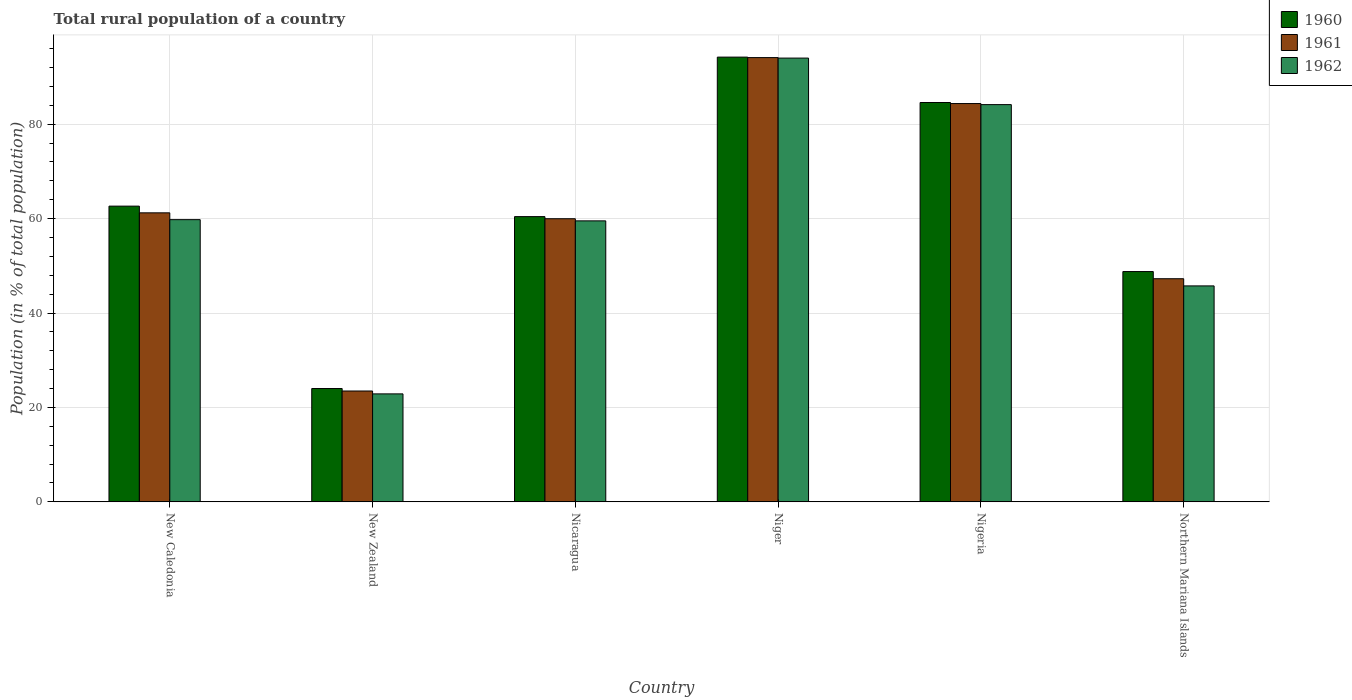How many different coloured bars are there?
Your response must be concise. 3. How many groups of bars are there?
Offer a terse response. 6. Are the number of bars on each tick of the X-axis equal?
Your answer should be compact. Yes. What is the label of the 1st group of bars from the left?
Keep it short and to the point. New Caledonia. In how many cases, is the number of bars for a given country not equal to the number of legend labels?
Provide a succinct answer. 0. What is the rural population in 1962 in New Caledonia?
Your answer should be compact. 59.78. Across all countries, what is the maximum rural population in 1961?
Your response must be concise. 94.1. Across all countries, what is the minimum rural population in 1962?
Your answer should be compact. 22.87. In which country was the rural population in 1961 maximum?
Offer a terse response. Niger. In which country was the rural population in 1960 minimum?
Keep it short and to the point. New Zealand. What is the total rural population in 1961 in the graph?
Your response must be concise. 370.39. What is the difference between the rural population in 1961 in New Zealand and that in Niger?
Give a very brief answer. -70.63. What is the difference between the rural population in 1962 in Niger and the rural population in 1960 in Nicaragua?
Offer a very short reply. 33.58. What is the average rural population in 1960 per country?
Provide a short and direct response. 62.44. What is the difference between the rural population of/in 1961 and rural population of/in 1960 in Nicaragua?
Your answer should be very brief. -0.45. In how many countries, is the rural population in 1960 greater than 28 %?
Offer a very short reply. 5. What is the ratio of the rural population in 1960 in New Caledonia to that in Niger?
Keep it short and to the point. 0.66. Is the rural population in 1962 in Niger less than that in Nigeria?
Give a very brief answer. No. What is the difference between the highest and the second highest rural population in 1960?
Offer a terse response. -21.95. What is the difference between the highest and the lowest rural population in 1962?
Give a very brief answer. 71.13. In how many countries, is the rural population in 1960 greater than the average rural population in 1960 taken over all countries?
Ensure brevity in your answer.  3. What does the 1st bar from the right in Nicaragua represents?
Give a very brief answer. 1962. Are all the bars in the graph horizontal?
Offer a terse response. No. What is the difference between two consecutive major ticks on the Y-axis?
Keep it short and to the point. 20. Where does the legend appear in the graph?
Provide a succinct answer. Top right. How many legend labels are there?
Offer a very short reply. 3. How are the legend labels stacked?
Keep it short and to the point. Vertical. What is the title of the graph?
Keep it short and to the point. Total rural population of a country. Does "1972" appear as one of the legend labels in the graph?
Give a very brief answer. No. What is the label or title of the X-axis?
Your answer should be very brief. Country. What is the label or title of the Y-axis?
Make the answer very short. Population (in % of total population). What is the Population (in % of total population) of 1960 in New Caledonia?
Keep it short and to the point. 62.64. What is the Population (in % of total population) in 1961 in New Caledonia?
Keep it short and to the point. 61.22. What is the Population (in % of total population) of 1962 in New Caledonia?
Your response must be concise. 59.78. What is the Population (in % of total population) in 1960 in New Zealand?
Keep it short and to the point. 24. What is the Population (in % of total population) of 1961 in New Zealand?
Provide a short and direct response. 23.48. What is the Population (in % of total population) in 1962 in New Zealand?
Keep it short and to the point. 22.87. What is the Population (in % of total population) in 1960 in Nicaragua?
Your answer should be very brief. 60.42. What is the Population (in % of total population) in 1961 in Nicaragua?
Your response must be concise. 59.97. What is the Population (in % of total population) in 1962 in Nicaragua?
Keep it short and to the point. 59.52. What is the Population (in % of total population) of 1960 in Niger?
Give a very brief answer. 94.21. What is the Population (in % of total population) in 1961 in Niger?
Provide a short and direct response. 94.1. What is the Population (in % of total population) of 1962 in Niger?
Make the answer very short. 94. What is the Population (in % of total population) of 1960 in Nigeria?
Give a very brief answer. 84.59. What is the Population (in % of total population) in 1961 in Nigeria?
Offer a very short reply. 84.37. What is the Population (in % of total population) in 1962 in Nigeria?
Keep it short and to the point. 84.14. What is the Population (in % of total population) in 1960 in Northern Mariana Islands?
Offer a very short reply. 48.78. What is the Population (in % of total population) in 1961 in Northern Mariana Islands?
Keep it short and to the point. 47.26. What is the Population (in % of total population) of 1962 in Northern Mariana Islands?
Provide a short and direct response. 45.74. Across all countries, what is the maximum Population (in % of total population) of 1960?
Your answer should be very brief. 94.21. Across all countries, what is the maximum Population (in % of total population) in 1961?
Your answer should be compact. 94.1. Across all countries, what is the maximum Population (in % of total population) of 1962?
Give a very brief answer. 94. Across all countries, what is the minimum Population (in % of total population) of 1960?
Provide a succinct answer. 24. Across all countries, what is the minimum Population (in % of total population) in 1961?
Give a very brief answer. 23.48. Across all countries, what is the minimum Population (in % of total population) of 1962?
Offer a very short reply. 22.87. What is the total Population (in % of total population) in 1960 in the graph?
Ensure brevity in your answer.  374.64. What is the total Population (in % of total population) of 1961 in the graph?
Ensure brevity in your answer.  370.39. What is the total Population (in % of total population) in 1962 in the graph?
Ensure brevity in your answer.  366.04. What is the difference between the Population (in % of total population) in 1960 in New Caledonia and that in New Zealand?
Your answer should be compact. 38.64. What is the difference between the Population (in % of total population) of 1961 in New Caledonia and that in New Zealand?
Offer a terse response. 37.74. What is the difference between the Population (in % of total population) of 1962 in New Caledonia and that in New Zealand?
Your response must be concise. 36.91. What is the difference between the Population (in % of total population) of 1960 in New Caledonia and that in Nicaragua?
Offer a terse response. 2.22. What is the difference between the Population (in % of total population) of 1961 in New Caledonia and that in Nicaragua?
Keep it short and to the point. 1.25. What is the difference between the Population (in % of total population) in 1962 in New Caledonia and that in Nicaragua?
Provide a succinct answer. 0.26. What is the difference between the Population (in % of total population) of 1960 in New Caledonia and that in Niger?
Keep it short and to the point. -31.57. What is the difference between the Population (in % of total population) in 1961 in New Caledonia and that in Niger?
Give a very brief answer. -32.88. What is the difference between the Population (in % of total population) of 1962 in New Caledonia and that in Niger?
Ensure brevity in your answer.  -34.22. What is the difference between the Population (in % of total population) in 1960 in New Caledonia and that in Nigeria?
Offer a very short reply. -21.95. What is the difference between the Population (in % of total population) of 1961 in New Caledonia and that in Nigeria?
Your answer should be compact. -23.15. What is the difference between the Population (in % of total population) of 1962 in New Caledonia and that in Nigeria?
Keep it short and to the point. -24.37. What is the difference between the Population (in % of total population) of 1960 in New Caledonia and that in Northern Mariana Islands?
Provide a succinct answer. 13.86. What is the difference between the Population (in % of total population) in 1961 in New Caledonia and that in Northern Mariana Islands?
Provide a short and direct response. 13.96. What is the difference between the Population (in % of total population) of 1962 in New Caledonia and that in Northern Mariana Islands?
Your response must be concise. 14.04. What is the difference between the Population (in % of total population) of 1960 in New Zealand and that in Nicaragua?
Your answer should be compact. -36.42. What is the difference between the Population (in % of total population) of 1961 in New Zealand and that in Nicaragua?
Make the answer very short. -36.49. What is the difference between the Population (in % of total population) of 1962 in New Zealand and that in Nicaragua?
Give a very brief answer. -36.65. What is the difference between the Population (in % of total population) in 1960 in New Zealand and that in Niger?
Your answer should be compact. -70.2. What is the difference between the Population (in % of total population) in 1961 in New Zealand and that in Niger?
Your response must be concise. -70.63. What is the difference between the Population (in % of total population) of 1962 in New Zealand and that in Niger?
Your response must be concise. -71.13. What is the difference between the Population (in % of total population) in 1960 in New Zealand and that in Nigeria?
Provide a succinct answer. -60.59. What is the difference between the Population (in % of total population) in 1961 in New Zealand and that in Nigeria?
Give a very brief answer. -60.89. What is the difference between the Population (in % of total population) in 1962 in New Zealand and that in Nigeria?
Keep it short and to the point. -61.27. What is the difference between the Population (in % of total population) of 1960 in New Zealand and that in Northern Mariana Islands?
Provide a short and direct response. -24.78. What is the difference between the Population (in % of total population) in 1961 in New Zealand and that in Northern Mariana Islands?
Keep it short and to the point. -23.78. What is the difference between the Population (in % of total population) of 1962 in New Zealand and that in Northern Mariana Islands?
Your answer should be compact. -22.87. What is the difference between the Population (in % of total population) of 1960 in Nicaragua and that in Niger?
Provide a short and direct response. -33.79. What is the difference between the Population (in % of total population) of 1961 in Nicaragua and that in Niger?
Give a very brief answer. -34.13. What is the difference between the Population (in % of total population) in 1962 in Nicaragua and that in Niger?
Provide a short and direct response. -34.48. What is the difference between the Population (in % of total population) in 1960 in Nicaragua and that in Nigeria?
Ensure brevity in your answer.  -24.17. What is the difference between the Population (in % of total population) of 1961 in Nicaragua and that in Nigeria?
Your response must be concise. -24.4. What is the difference between the Population (in % of total population) of 1962 in Nicaragua and that in Nigeria?
Keep it short and to the point. -24.62. What is the difference between the Population (in % of total population) of 1960 in Nicaragua and that in Northern Mariana Islands?
Give a very brief answer. 11.64. What is the difference between the Population (in % of total population) of 1961 in Nicaragua and that in Northern Mariana Islands?
Ensure brevity in your answer.  12.71. What is the difference between the Population (in % of total population) in 1962 in Nicaragua and that in Northern Mariana Islands?
Give a very brief answer. 13.78. What is the difference between the Population (in % of total population) of 1960 in Niger and that in Nigeria?
Keep it short and to the point. 9.62. What is the difference between the Population (in % of total population) in 1961 in Niger and that in Nigeria?
Provide a short and direct response. 9.74. What is the difference between the Population (in % of total population) of 1962 in Niger and that in Nigeria?
Your answer should be very brief. 9.86. What is the difference between the Population (in % of total population) in 1960 in Niger and that in Northern Mariana Islands?
Offer a very short reply. 45.43. What is the difference between the Population (in % of total population) of 1961 in Niger and that in Northern Mariana Islands?
Keep it short and to the point. 46.84. What is the difference between the Population (in % of total population) in 1962 in Niger and that in Northern Mariana Islands?
Your response must be concise. 48.26. What is the difference between the Population (in % of total population) in 1960 in Nigeria and that in Northern Mariana Islands?
Ensure brevity in your answer.  35.81. What is the difference between the Population (in % of total population) in 1961 in Nigeria and that in Northern Mariana Islands?
Offer a terse response. 37.11. What is the difference between the Population (in % of total population) in 1962 in Nigeria and that in Northern Mariana Islands?
Offer a terse response. 38.4. What is the difference between the Population (in % of total population) of 1960 in New Caledonia and the Population (in % of total population) of 1961 in New Zealand?
Offer a terse response. 39.16. What is the difference between the Population (in % of total population) in 1960 in New Caledonia and the Population (in % of total population) in 1962 in New Zealand?
Your response must be concise. 39.77. What is the difference between the Population (in % of total population) of 1961 in New Caledonia and the Population (in % of total population) of 1962 in New Zealand?
Give a very brief answer. 38.35. What is the difference between the Population (in % of total population) in 1960 in New Caledonia and the Population (in % of total population) in 1961 in Nicaragua?
Make the answer very short. 2.67. What is the difference between the Population (in % of total population) in 1960 in New Caledonia and the Population (in % of total population) in 1962 in Nicaragua?
Ensure brevity in your answer.  3.12. What is the difference between the Population (in % of total population) in 1961 in New Caledonia and the Population (in % of total population) in 1962 in Nicaragua?
Offer a very short reply. 1.7. What is the difference between the Population (in % of total population) in 1960 in New Caledonia and the Population (in % of total population) in 1961 in Niger?
Your answer should be very brief. -31.46. What is the difference between the Population (in % of total population) in 1960 in New Caledonia and the Population (in % of total population) in 1962 in Niger?
Your answer should be compact. -31.36. What is the difference between the Population (in % of total population) of 1961 in New Caledonia and the Population (in % of total population) of 1962 in Niger?
Ensure brevity in your answer.  -32.78. What is the difference between the Population (in % of total population) in 1960 in New Caledonia and the Population (in % of total population) in 1961 in Nigeria?
Provide a short and direct response. -21.73. What is the difference between the Population (in % of total population) in 1960 in New Caledonia and the Population (in % of total population) in 1962 in Nigeria?
Make the answer very short. -21.5. What is the difference between the Population (in % of total population) of 1961 in New Caledonia and the Population (in % of total population) of 1962 in Nigeria?
Give a very brief answer. -22.92. What is the difference between the Population (in % of total population) of 1960 in New Caledonia and the Population (in % of total population) of 1961 in Northern Mariana Islands?
Your answer should be very brief. 15.38. What is the difference between the Population (in % of total population) in 1960 in New Caledonia and the Population (in % of total population) in 1962 in Northern Mariana Islands?
Offer a very short reply. 16.9. What is the difference between the Population (in % of total population) of 1961 in New Caledonia and the Population (in % of total population) of 1962 in Northern Mariana Islands?
Keep it short and to the point. 15.48. What is the difference between the Population (in % of total population) in 1960 in New Zealand and the Population (in % of total population) in 1961 in Nicaragua?
Make the answer very short. -35.97. What is the difference between the Population (in % of total population) in 1960 in New Zealand and the Population (in % of total population) in 1962 in Nicaragua?
Your answer should be compact. -35.52. What is the difference between the Population (in % of total population) of 1961 in New Zealand and the Population (in % of total population) of 1962 in Nicaragua?
Your answer should be compact. -36.04. What is the difference between the Population (in % of total population) of 1960 in New Zealand and the Population (in % of total population) of 1961 in Niger?
Provide a succinct answer. -70.1. What is the difference between the Population (in % of total population) of 1960 in New Zealand and the Population (in % of total population) of 1962 in Niger?
Your response must be concise. -70. What is the difference between the Population (in % of total population) in 1961 in New Zealand and the Population (in % of total population) in 1962 in Niger?
Keep it short and to the point. -70.53. What is the difference between the Population (in % of total population) of 1960 in New Zealand and the Population (in % of total population) of 1961 in Nigeria?
Your response must be concise. -60.37. What is the difference between the Population (in % of total population) in 1960 in New Zealand and the Population (in % of total population) in 1962 in Nigeria?
Make the answer very short. -60.14. What is the difference between the Population (in % of total population) of 1961 in New Zealand and the Population (in % of total population) of 1962 in Nigeria?
Your answer should be compact. -60.67. What is the difference between the Population (in % of total population) of 1960 in New Zealand and the Population (in % of total population) of 1961 in Northern Mariana Islands?
Offer a very short reply. -23.26. What is the difference between the Population (in % of total population) in 1960 in New Zealand and the Population (in % of total population) in 1962 in Northern Mariana Islands?
Your answer should be very brief. -21.74. What is the difference between the Population (in % of total population) in 1961 in New Zealand and the Population (in % of total population) in 1962 in Northern Mariana Islands?
Give a very brief answer. -22.27. What is the difference between the Population (in % of total population) in 1960 in Nicaragua and the Population (in % of total population) in 1961 in Niger?
Ensure brevity in your answer.  -33.69. What is the difference between the Population (in % of total population) of 1960 in Nicaragua and the Population (in % of total population) of 1962 in Niger?
Offer a very short reply. -33.58. What is the difference between the Population (in % of total population) in 1961 in Nicaragua and the Population (in % of total population) in 1962 in Niger?
Ensure brevity in your answer.  -34.03. What is the difference between the Population (in % of total population) of 1960 in Nicaragua and the Population (in % of total population) of 1961 in Nigeria?
Your response must be concise. -23.95. What is the difference between the Population (in % of total population) of 1960 in Nicaragua and the Population (in % of total population) of 1962 in Nigeria?
Your answer should be compact. -23.72. What is the difference between the Population (in % of total population) of 1961 in Nicaragua and the Population (in % of total population) of 1962 in Nigeria?
Give a very brief answer. -24.17. What is the difference between the Population (in % of total population) in 1960 in Nicaragua and the Population (in % of total population) in 1961 in Northern Mariana Islands?
Provide a short and direct response. 13.16. What is the difference between the Population (in % of total population) of 1960 in Nicaragua and the Population (in % of total population) of 1962 in Northern Mariana Islands?
Your answer should be very brief. 14.68. What is the difference between the Population (in % of total population) of 1961 in Nicaragua and the Population (in % of total population) of 1962 in Northern Mariana Islands?
Provide a succinct answer. 14.23. What is the difference between the Population (in % of total population) in 1960 in Niger and the Population (in % of total population) in 1961 in Nigeria?
Your answer should be very brief. 9.84. What is the difference between the Population (in % of total population) in 1960 in Niger and the Population (in % of total population) in 1962 in Nigeria?
Give a very brief answer. 10.06. What is the difference between the Population (in % of total population) of 1961 in Niger and the Population (in % of total population) of 1962 in Nigeria?
Your answer should be very brief. 9.96. What is the difference between the Population (in % of total population) of 1960 in Niger and the Population (in % of total population) of 1961 in Northern Mariana Islands?
Your answer should be very brief. 46.95. What is the difference between the Population (in % of total population) in 1960 in Niger and the Population (in % of total population) in 1962 in Northern Mariana Islands?
Ensure brevity in your answer.  48.47. What is the difference between the Population (in % of total population) in 1961 in Niger and the Population (in % of total population) in 1962 in Northern Mariana Islands?
Provide a short and direct response. 48.36. What is the difference between the Population (in % of total population) of 1960 in Nigeria and the Population (in % of total population) of 1961 in Northern Mariana Islands?
Provide a short and direct response. 37.33. What is the difference between the Population (in % of total population) of 1960 in Nigeria and the Population (in % of total population) of 1962 in Northern Mariana Islands?
Give a very brief answer. 38.85. What is the difference between the Population (in % of total population) in 1961 in Nigeria and the Population (in % of total population) in 1962 in Northern Mariana Islands?
Offer a very short reply. 38.63. What is the average Population (in % of total population) in 1960 per country?
Ensure brevity in your answer.  62.44. What is the average Population (in % of total population) in 1961 per country?
Provide a short and direct response. 61.73. What is the average Population (in % of total population) in 1962 per country?
Provide a short and direct response. 61.01. What is the difference between the Population (in % of total population) in 1960 and Population (in % of total population) in 1961 in New Caledonia?
Offer a very short reply. 1.42. What is the difference between the Population (in % of total population) in 1960 and Population (in % of total population) in 1962 in New Caledonia?
Your answer should be compact. 2.86. What is the difference between the Population (in % of total population) in 1961 and Population (in % of total population) in 1962 in New Caledonia?
Offer a very short reply. 1.44. What is the difference between the Population (in % of total population) in 1960 and Population (in % of total population) in 1961 in New Zealand?
Provide a succinct answer. 0.53. What is the difference between the Population (in % of total population) of 1960 and Population (in % of total population) of 1962 in New Zealand?
Offer a terse response. 1.14. What is the difference between the Population (in % of total population) in 1961 and Population (in % of total population) in 1962 in New Zealand?
Your answer should be very brief. 0.61. What is the difference between the Population (in % of total population) of 1960 and Population (in % of total population) of 1961 in Nicaragua?
Offer a terse response. 0.45. What is the difference between the Population (in % of total population) in 1960 and Population (in % of total population) in 1962 in Nicaragua?
Offer a terse response. 0.9. What is the difference between the Population (in % of total population) in 1961 and Population (in % of total population) in 1962 in Nicaragua?
Offer a terse response. 0.45. What is the difference between the Population (in % of total population) in 1960 and Population (in % of total population) in 1961 in Niger?
Provide a short and direct response. 0.1. What is the difference between the Population (in % of total population) of 1960 and Population (in % of total population) of 1962 in Niger?
Your answer should be compact. 0.21. What is the difference between the Population (in % of total population) in 1961 and Population (in % of total population) in 1962 in Niger?
Your answer should be very brief. 0.1. What is the difference between the Population (in % of total population) in 1960 and Population (in % of total population) in 1961 in Nigeria?
Ensure brevity in your answer.  0.22. What is the difference between the Population (in % of total population) of 1960 and Population (in % of total population) of 1962 in Nigeria?
Offer a very short reply. 0.45. What is the difference between the Population (in % of total population) of 1961 and Population (in % of total population) of 1962 in Nigeria?
Offer a terse response. 0.23. What is the difference between the Population (in % of total population) of 1960 and Population (in % of total population) of 1961 in Northern Mariana Islands?
Keep it short and to the point. 1.52. What is the difference between the Population (in % of total population) of 1960 and Population (in % of total population) of 1962 in Northern Mariana Islands?
Keep it short and to the point. 3.04. What is the difference between the Population (in % of total population) of 1961 and Population (in % of total population) of 1962 in Northern Mariana Islands?
Your answer should be very brief. 1.52. What is the ratio of the Population (in % of total population) of 1960 in New Caledonia to that in New Zealand?
Your answer should be very brief. 2.61. What is the ratio of the Population (in % of total population) in 1961 in New Caledonia to that in New Zealand?
Make the answer very short. 2.61. What is the ratio of the Population (in % of total population) of 1962 in New Caledonia to that in New Zealand?
Offer a terse response. 2.61. What is the ratio of the Population (in % of total population) of 1960 in New Caledonia to that in Nicaragua?
Give a very brief answer. 1.04. What is the ratio of the Population (in % of total population) in 1961 in New Caledonia to that in Nicaragua?
Keep it short and to the point. 1.02. What is the ratio of the Population (in % of total population) in 1960 in New Caledonia to that in Niger?
Give a very brief answer. 0.66. What is the ratio of the Population (in % of total population) in 1961 in New Caledonia to that in Niger?
Provide a short and direct response. 0.65. What is the ratio of the Population (in % of total population) of 1962 in New Caledonia to that in Niger?
Ensure brevity in your answer.  0.64. What is the ratio of the Population (in % of total population) in 1960 in New Caledonia to that in Nigeria?
Your response must be concise. 0.74. What is the ratio of the Population (in % of total population) of 1961 in New Caledonia to that in Nigeria?
Your answer should be very brief. 0.73. What is the ratio of the Population (in % of total population) in 1962 in New Caledonia to that in Nigeria?
Keep it short and to the point. 0.71. What is the ratio of the Population (in % of total population) of 1960 in New Caledonia to that in Northern Mariana Islands?
Keep it short and to the point. 1.28. What is the ratio of the Population (in % of total population) of 1961 in New Caledonia to that in Northern Mariana Islands?
Make the answer very short. 1.3. What is the ratio of the Population (in % of total population) in 1962 in New Caledonia to that in Northern Mariana Islands?
Provide a succinct answer. 1.31. What is the ratio of the Population (in % of total population) of 1960 in New Zealand to that in Nicaragua?
Offer a very short reply. 0.4. What is the ratio of the Population (in % of total population) in 1961 in New Zealand to that in Nicaragua?
Provide a succinct answer. 0.39. What is the ratio of the Population (in % of total population) in 1962 in New Zealand to that in Nicaragua?
Keep it short and to the point. 0.38. What is the ratio of the Population (in % of total population) in 1960 in New Zealand to that in Niger?
Offer a very short reply. 0.25. What is the ratio of the Population (in % of total population) of 1961 in New Zealand to that in Niger?
Offer a terse response. 0.25. What is the ratio of the Population (in % of total population) in 1962 in New Zealand to that in Niger?
Provide a succinct answer. 0.24. What is the ratio of the Population (in % of total population) of 1960 in New Zealand to that in Nigeria?
Provide a short and direct response. 0.28. What is the ratio of the Population (in % of total population) in 1961 in New Zealand to that in Nigeria?
Your response must be concise. 0.28. What is the ratio of the Population (in % of total population) of 1962 in New Zealand to that in Nigeria?
Offer a terse response. 0.27. What is the ratio of the Population (in % of total population) of 1960 in New Zealand to that in Northern Mariana Islands?
Your answer should be compact. 0.49. What is the ratio of the Population (in % of total population) of 1961 in New Zealand to that in Northern Mariana Islands?
Make the answer very short. 0.5. What is the ratio of the Population (in % of total population) of 1962 in New Zealand to that in Northern Mariana Islands?
Provide a short and direct response. 0.5. What is the ratio of the Population (in % of total population) of 1960 in Nicaragua to that in Niger?
Provide a succinct answer. 0.64. What is the ratio of the Population (in % of total population) of 1961 in Nicaragua to that in Niger?
Your answer should be compact. 0.64. What is the ratio of the Population (in % of total population) of 1962 in Nicaragua to that in Niger?
Your answer should be very brief. 0.63. What is the ratio of the Population (in % of total population) of 1961 in Nicaragua to that in Nigeria?
Ensure brevity in your answer.  0.71. What is the ratio of the Population (in % of total population) in 1962 in Nicaragua to that in Nigeria?
Offer a very short reply. 0.71. What is the ratio of the Population (in % of total population) of 1960 in Nicaragua to that in Northern Mariana Islands?
Keep it short and to the point. 1.24. What is the ratio of the Population (in % of total population) of 1961 in Nicaragua to that in Northern Mariana Islands?
Ensure brevity in your answer.  1.27. What is the ratio of the Population (in % of total population) in 1962 in Nicaragua to that in Northern Mariana Islands?
Provide a short and direct response. 1.3. What is the ratio of the Population (in % of total population) of 1960 in Niger to that in Nigeria?
Provide a short and direct response. 1.11. What is the ratio of the Population (in % of total population) in 1961 in Niger to that in Nigeria?
Provide a short and direct response. 1.12. What is the ratio of the Population (in % of total population) in 1962 in Niger to that in Nigeria?
Provide a short and direct response. 1.12. What is the ratio of the Population (in % of total population) of 1960 in Niger to that in Northern Mariana Islands?
Provide a short and direct response. 1.93. What is the ratio of the Population (in % of total population) of 1961 in Niger to that in Northern Mariana Islands?
Give a very brief answer. 1.99. What is the ratio of the Population (in % of total population) in 1962 in Niger to that in Northern Mariana Islands?
Provide a succinct answer. 2.06. What is the ratio of the Population (in % of total population) in 1960 in Nigeria to that in Northern Mariana Islands?
Ensure brevity in your answer.  1.73. What is the ratio of the Population (in % of total population) of 1961 in Nigeria to that in Northern Mariana Islands?
Your answer should be compact. 1.79. What is the ratio of the Population (in % of total population) in 1962 in Nigeria to that in Northern Mariana Islands?
Offer a terse response. 1.84. What is the difference between the highest and the second highest Population (in % of total population) of 1960?
Provide a succinct answer. 9.62. What is the difference between the highest and the second highest Population (in % of total population) in 1961?
Offer a terse response. 9.74. What is the difference between the highest and the second highest Population (in % of total population) in 1962?
Your response must be concise. 9.86. What is the difference between the highest and the lowest Population (in % of total population) of 1960?
Ensure brevity in your answer.  70.2. What is the difference between the highest and the lowest Population (in % of total population) of 1961?
Provide a succinct answer. 70.63. What is the difference between the highest and the lowest Population (in % of total population) of 1962?
Your answer should be compact. 71.13. 